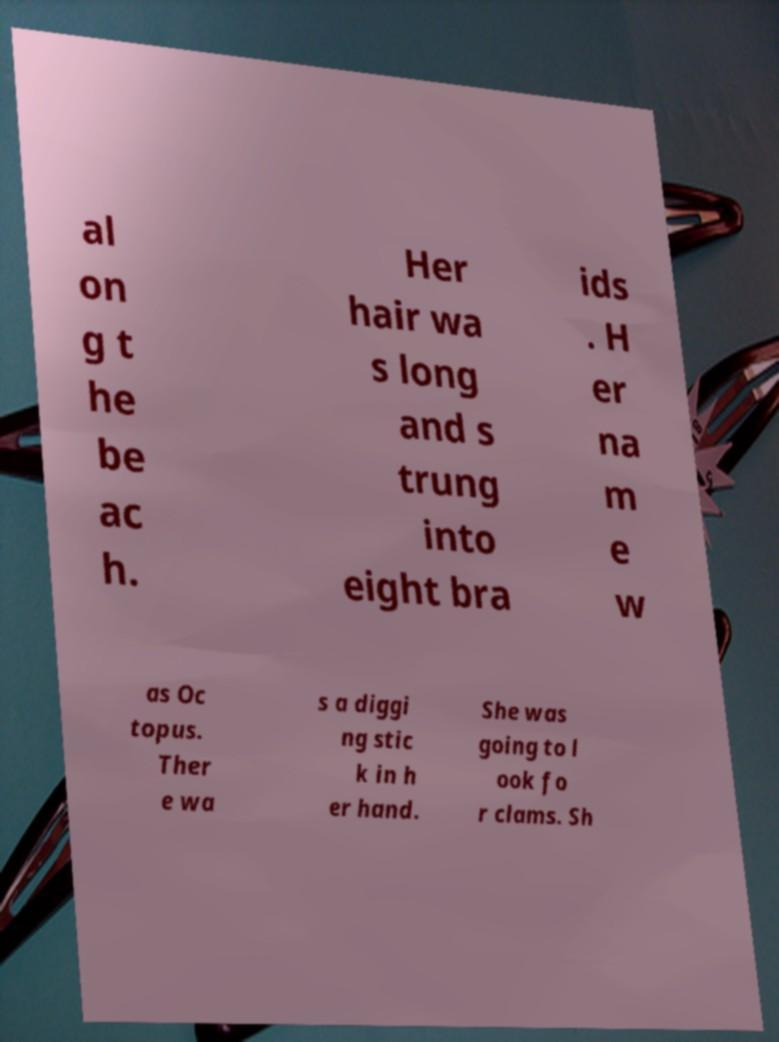For documentation purposes, I need the text within this image transcribed. Could you provide that? al on g t he be ac h. Her hair wa s long and s trung into eight bra ids . H er na m e w as Oc topus. Ther e wa s a diggi ng stic k in h er hand. She was going to l ook fo r clams. Sh 